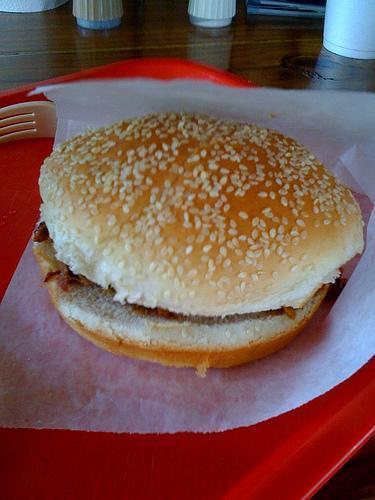How many dining tables are there?
Give a very brief answer. 2. 